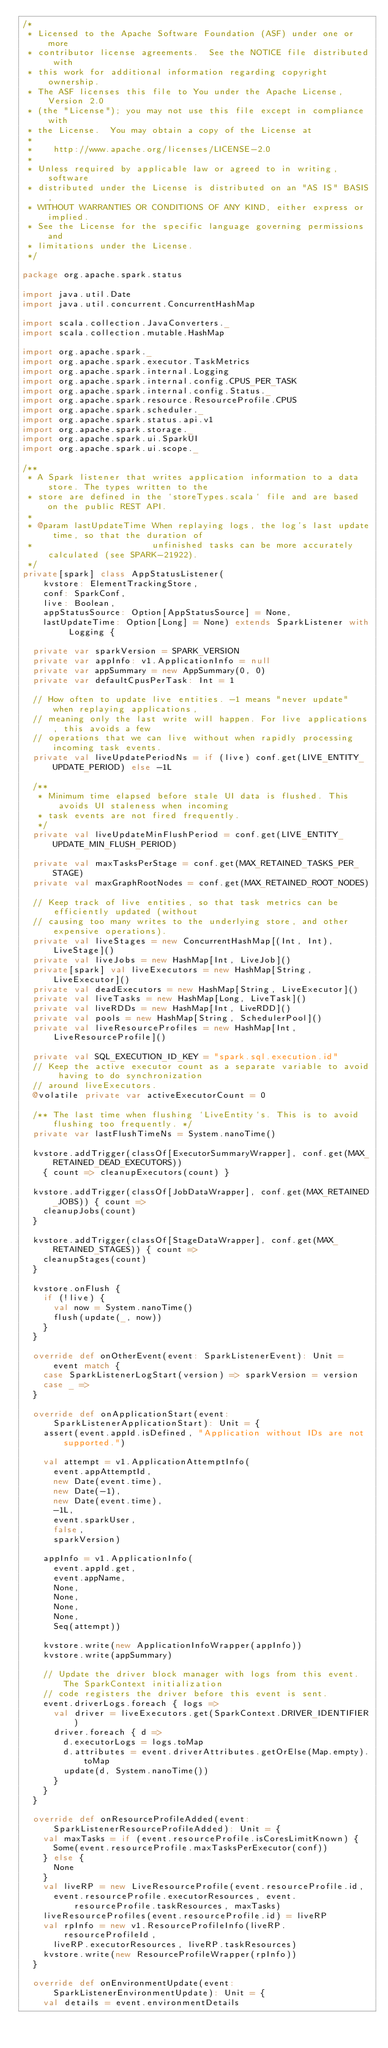Convert code to text. <code><loc_0><loc_0><loc_500><loc_500><_Scala_>/*
 * Licensed to the Apache Software Foundation (ASF) under one or more
 * contributor license agreements.  See the NOTICE file distributed with
 * this work for additional information regarding copyright ownership.
 * The ASF licenses this file to You under the Apache License, Version 2.0
 * (the "License"); you may not use this file except in compliance with
 * the License.  You may obtain a copy of the License at
 *
 *    http://www.apache.org/licenses/LICENSE-2.0
 *
 * Unless required by applicable law or agreed to in writing, software
 * distributed under the License is distributed on an "AS IS" BASIS,
 * WITHOUT WARRANTIES OR CONDITIONS OF ANY KIND, either express or implied.
 * See the License for the specific language governing permissions and
 * limitations under the License.
 */

package org.apache.spark.status

import java.util.Date
import java.util.concurrent.ConcurrentHashMap

import scala.collection.JavaConverters._
import scala.collection.mutable.HashMap

import org.apache.spark._
import org.apache.spark.executor.TaskMetrics
import org.apache.spark.internal.Logging
import org.apache.spark.internal.config.CPUS_PER_TASK
import org.apache.spark.internal.config.Status._
import org.apache.spark.resource.ResourceProfile.CPUS
import org.apache.spark.scheduler._
import org.apache.spark.status.api.v1
import org.apache.spark.storage._
import org.apache.spark.ui.SparkUI
import org.apache.spark.ui.scope._

/**
 * A Spark listener that writes application information to a data store. The types written to the
 * store are defined in the `storeTypes.scala` file and are based on the public REST API.
 *
 * @param lastUpdateTime When replaying logs, the log's last update time, so that the duration of
 *                       unfinished tasks can be more accurately calculated (see SPARK-21922).
 */
private[spark] class AppStatusListener(
    kvstore: ElementTrackingStore,
    conf: SparkConf,
    live: Boolean,
    appStatusSource: Option[AppStatusSource] = None,
    lastUpdateTime: Option[Long] = None) extends SparkListener with Logging {

  private var sparkVersion = SPARK_VERSION
  private var appInfo: v1.ApplicationInfo = null
  private var appSummary = new AppSummary(0, 0)
  private var defaultCpusPerTask: Int = 1

  // How often to update live entities. -1 means "never update" when replaying applications,
  // meaning only the last write will happen. For live applications, this avoids a few
  // operations that we can live without when rapidly processing incoming task events.
  private val liveUpdatePeriodNs = if (live) conf.get(LIVE_ENTITY_UPDATE_PERIOD) else -1L

  /**
   * Minimum time elapsed before stale UI data is flushed. This avoids UI staleness when incoming
   * task events are not fired frequently.
   */
  private val liveUpdateMinFlushPeriod = conf.get(LIVE_ENTITY_UPDATE_MIN_FLUSH_PERIOD)

  private val maxTasksPerStage = conf.get(MAX_RETAINED_TASKS_PER_STAGE)
  private val maxGraphRootNodes = conf.get(MAX_RETAINED_ROOT_NODES)

  // Keep track of live entities, so that task metrics can be efficiently updated (without
  // causing too many writes to the underlying store, and other expensive operations).
  private val liveStages = new ConcurrentHashMap[(Int, Int), LiveStage]()
  private val liveJobs = new HashMap[Int, LiveJob]()
  private[spark] val liveExecutors = new HashMap[String, LiveExecutor]()
  private val deadExecutors = new HashMap[String, LiveExecutor]()
  private val liveTasks = new HashMap[Long, LiveTask]()
  private val liveRDDs = new HashMap[Int, LiveRDD]()
  private val pools = new HashMap[String, SchedulerPool]()
  private val liveResourceProfiles = new HashMap[Int, LiveResourceProfile]()

  private val SQL_EXECUTION_ID_KEY = "spark.sql.execution.id"
  // Keep the active executor count as a separate variable to avoid having to do synchronization
  // around liveExecutors.
  @volatile private var activeExecutorCount = 0

  /** The last time when flushing `LiveEntity`s. This is to avoid flushing too frequently. */
  private var lastFlushTimeNs = System.nanoTime()

  kvstore.addTrigger(classOf[ExecutorSummaryWrapper], conf.get(MAX_RETAINED_DEAD_EXECUTORS))
    { count => cleanupExecutors(count) }

  kvstore.addTrigger(classOf[JobDataWrapper], conf.get(MAX_RETAINED_JOBS)) { count =>
    cleanupJobs(count)
  }

  kvstore.addTrigger(classOf[StageDataWrapper], conf.get(MAX_RETAINED_STAGES)) { count =>
    cleanupStages(count)
  }

  kvstore.onFlush {
    if (!live) {
      val now = System.nanoTime()
      flush(update(_, now))
    }
  }

  override def onOtherEvent(event: SparkListenerEvent): Unit = event match {
    case SparkListenerLogStart(version) => sparkVersion = version
    case _ =>
  }

  override def onApplicationStart(event: SparkListenerApplicationStart): Unit = {
    assert(event.appId.isDefined, "Application without IDs are not supported.")

    val attempt = v1.ApplicationAttemptInfo(
      event.appAttemptId,
      new Date(event.time),
      new Date(-1),
      new Date(event.time),
      -1L,
      event.sparkUser,
      false,
      sparkVersion)

    appInfo = v1.ApplicationInfo(
      event.appId.get,
      event.appName,
      None,
      None,
      None,
      None,
      Seq(attempt))

    kvstore.write(new ApplicationInfoWrapper(appInfo))
    kvstore.write(appSummary)

    // Update the driver block manager with logs from this event. The SparkContext initialization
    // code registers the driver before this event is sent.
    event.driverLogs.foreach { logs =>
      val driver = liveExecutors.get(SparkContext.DRIVER_IDENTIFIER)
      driver.foreach { d =>
        d.executorLogs = logs.toMap
        d.attributes = event.driverAttributes.getOrElse(Map.empty).toMap
        update(d, System.nanoTime())
      }
    }
  }

  override def onResourceProfileAdded(event: SparkListenerResourceProfileAdded): Unit = {
    val maxTasks = if (event.resourceProfile.isCoresLimitKnown) {
      Some(event.resourceProfile.maxTasksPerExecutor(conf))
    } else {
      None
    }
    val liveRP = new LiveResourceProfile(event.resourceProfile.id,
      event.resourceProfile.executorResources, event.resourceProfile.taskResources, maxTasks)
    liveResourceProfiles(event.resourceProfile.id) = liveRP
    val rpInfo = new v1.ResourceProfileInfo(liveRP.resourceProfileId,
      liveRP.executorResources, liveRP.taskResources)
    kvstore.write(new ResourceProfileWrapper(rpInfo))
  }

  override def onEnvironmentUpdate(event: SparkListenerEnvironmentUpdate): Unit = {
    val details = event.environmentDetails
</code> 